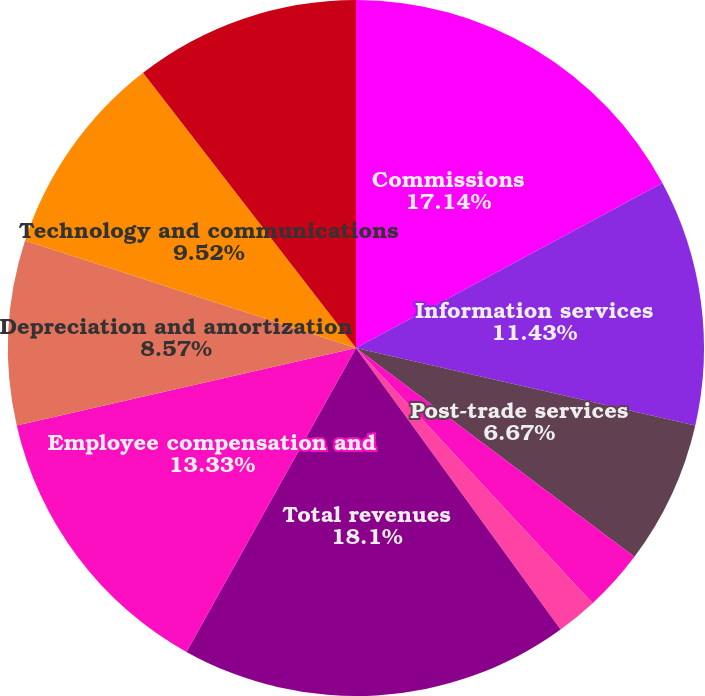Convert chart to OTSL. <chart><loc_0><loc_0><loc_500><loc_500><pie_chart><fcel>Commissions<fcel>Information services<fcel>Post-trade services<fcel>Investment income<fcel>Other<fcel>Total revenues<fcel>Employee compensation and<fcel>Depreciation and amortization<fcel>Technology and communications<fcel>Professional and consulting<nl><fcel>17.14%<fcel>11.43%<fcel>6.67%<fcel>2.86%<fcel>1.9%<fcel>18.1%<fcel>13.33%<fcel>8.57%<fcel>9.52%<fcel>10.48%<nl></chart> 